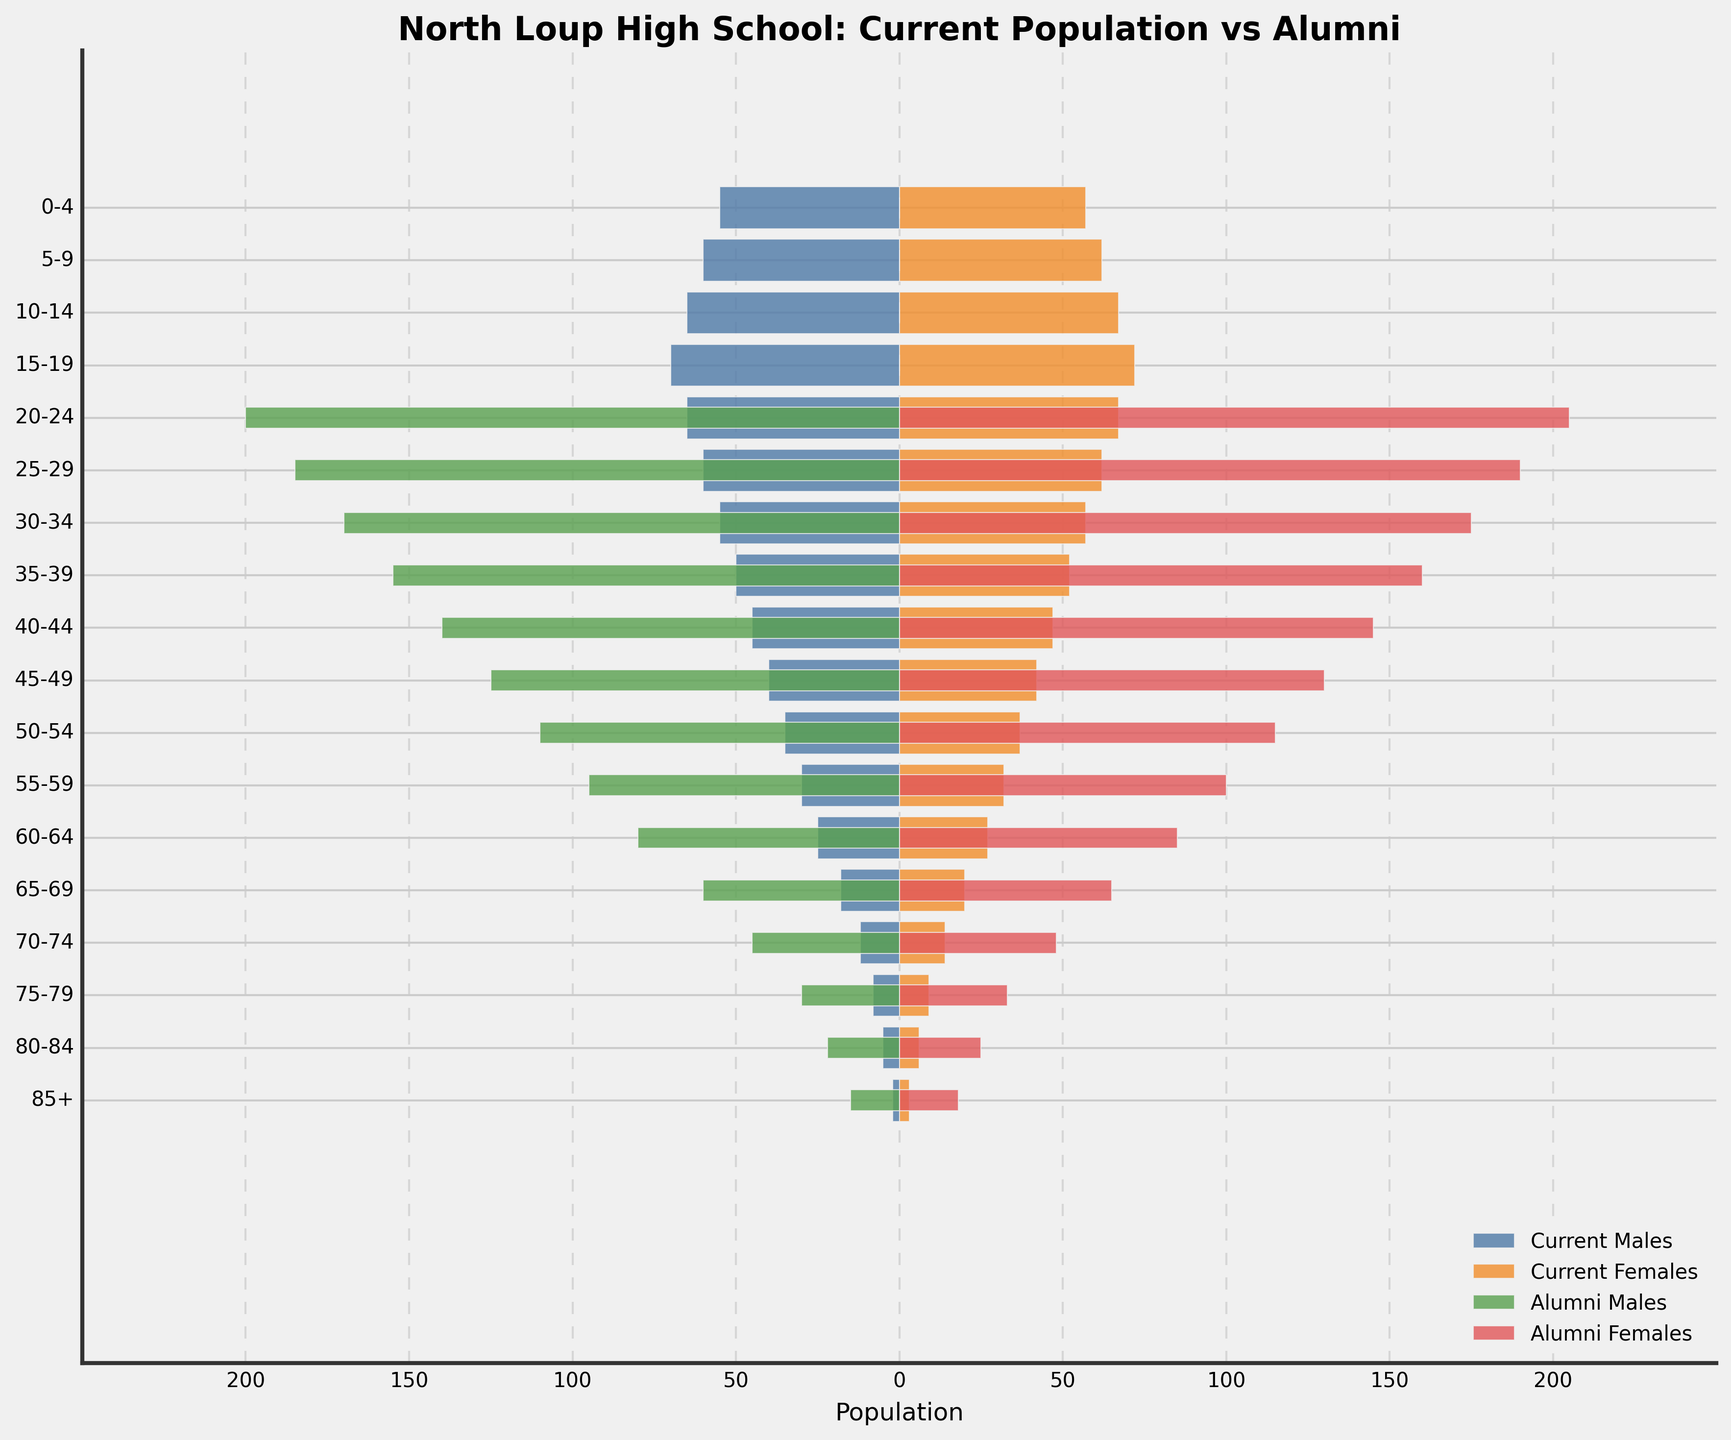What's the title of the plot? The title of the plot is prominently displayed at the top of the figure. It is written in a larger, bold font to stand out.
Answer: North Loup High School: Current Population vs Alumni What is the age group with the highest number of current population males? To find the age group with the highest number of current population males, observe the length of the blue bars on the left side of the central vertical line. The longest blue bar corresponds to age group 15-19.
Answer: 15-19 Which alumni group (males or females) has a higher population in the 60-64 age range? Compare the lengths of the green and red bars representing alumni males and alumni females for the 60-64 age range. The red bar, representing alumni females, is slightly longer.
Answer: Alumni Females What is the ratio of current population females to males in the 40-44 age group? Count the lengths of the orange and blue bars representing current population females and males for the 40-44 age group. The count for females is 47 while for males it is 45. The ratio is 47:45.
Answer: 47:45 Which age group has the smallest difference between current males and females? To determine the smallest difference between current population males and females, examine the lengths of the blue and orange bars for each age group and note the differences. The smallest difference is in the 85+ age group, with a difference of 1.
Answer: 85+ What is the total number of current population males and females under age 10? Sum the population for both males and females in the 0-4 and 5-9 age groups. Males: 55 (0-4) + 60 (5-9) = 115. Females: 57 (0-4) + 62 (5-9) = 119. The total is 115 + 119.
Answer: 234 In which age group is the alumni male population the highest? Evaluate the lengths of the green bars on the left side of the vertical line for each age group. The bar for the age group 20-24 is the longest, indicating the highest alumni male population.
Answer: 20-24 How many more alumni females are there than current females in the 55-59 age group? Compare the lengths of the red and orange bars for the 55-59 age group. Alumni females are 100, and current females are 32. The difference is 100 - 32.
Answer: 68 Which group sees a decline in population moving from the age group 15-19 to 20-24: current males or females? Explain the trend. Observe the lengths of the blue and orange bars for the age groups 15-19 and 20-24. Both blue (males) and orange (females) bars are shorter in the 20-24 age group compared to the 15-19 age group, indicating a decline in population for both genders.
Answer: Both What is the median age group for current females? Identify the central position of the orange bars representing current females. Since the data is divided into 18 age groups, the median position would be the 9th and 10th age groups (50-54 and 55-59).
Answer: 50-59 